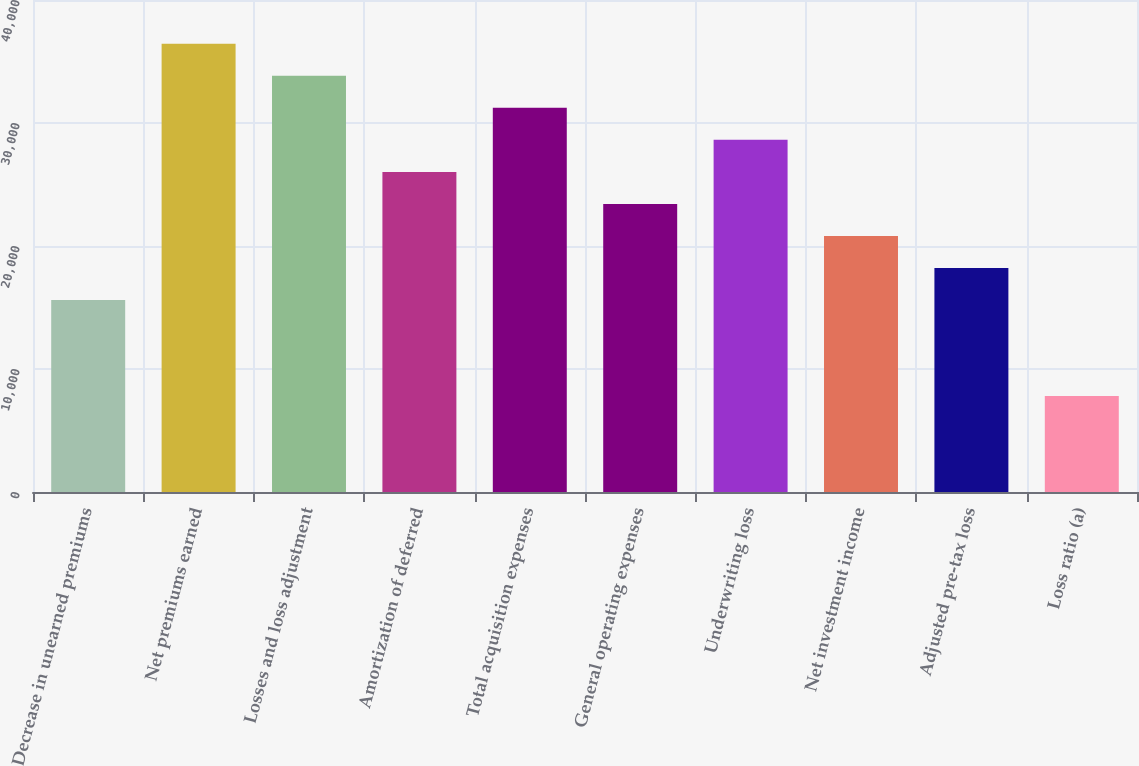Convert chart to OTSL. <chart><loc_0><loc_0><loc_500><loc_500><bar_chart><fcel>Decrease in unearned premiums<fcel>Net premiums earned<fcel>Losses and loss adjustment<fcel>Amortization of deferred<fcel>Total acquisition expenses<fcel>General operating expenses<fcel>Underwriting loss<fcel>Net investment income<fcel>Adjusted pre-tax loss<fcel>Loss ratio (a)<nl><fcel>15617.2<fcel>36434.8<fcel>33832.6<fcel>26026<fcel>31230.4<fcel>23423.8<fcel>28628.2<fcel>20821.6<fcel>18219.4<fcel>7810.6<nl></chart> 